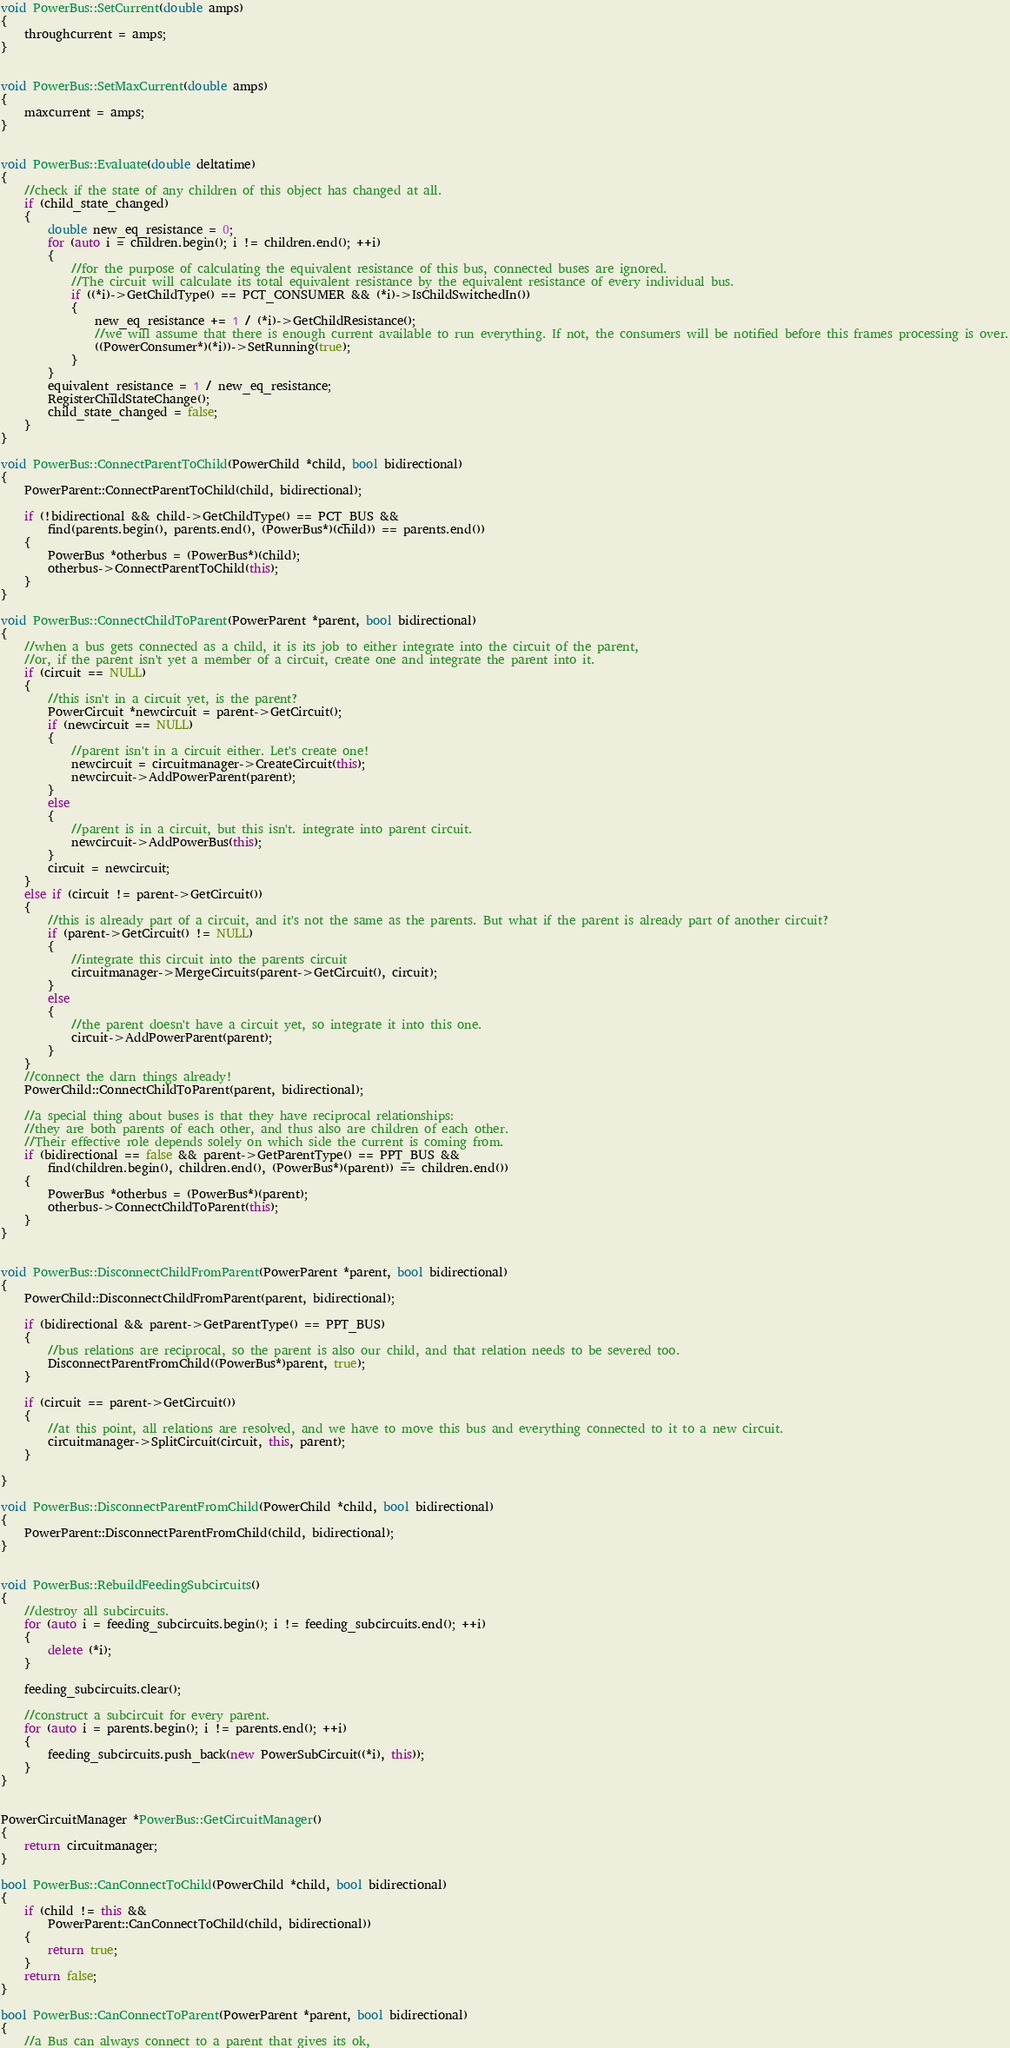<code> <loc_0><loc_0><loc_500><loc_500><_C++_>
void PowerBus::SetCurrent(double amps)
{
	throughcurrent = amps;
}


void PowerBus::SetMaxCurrent(double amps)
{
	maxcurrent = amps;
}


void PowerBus::Evaluate(double deltatime)
{
	//check if the state of any children of this object has changed at all.
	if (child_state_changed)
	{
		double new_eq_resistance = 0;
		for (auto i = children.begin(); i != children.end(); ++i)
		{
			//for the purpose of calculating the equivalent resistance of this bus, connected buses are ignored.
			//The circuit will calculate its total equivalent resistance by the equivalent resistance of every individual bus.
			if ((*i)->GetChildType() == PCT_CONSUMER && (*i)->IsChildSwitchedIn())
			{
				new_eq_resistance += 1 / (*i)->GetChildResistance();
				//we will assume that there is enough current available to run everything. If not, the consumers will be notified before this frames processing is over.
				((PowerConsumer*)(*i))->SetRunning(true);
			}
		}
		equivalent_resistance = 1 / new_eq_resistance;
		RegisterChildStateChange();
		child_state_changed = false;
	}
}

void PowerBus::ConnectParentToChild(PowerChild *child, bool bidirectional)
{
	PowerParent::ConnectParentToChild(child, bidirectional);

	if (!bidirectional && child->GetChildType() == PCT_BUS &&
		find(parents.begin(), parents.end(), (PowerBus*)(child)) == parents.end())
	{
		PowerBus *otherbus = (PowerBus*)(child);
		otherbus->ConnectParentToChild(this);
	}
}

void PowerBus::ConnectChildToParent(PowerParent *parent, bool bidirectional)
{
	//when a bus gets connected as a child, it is its job to either integrate into the circuit of the parent,
	//or, if the parent isn't yet a member of a circuit, create one and integrate the parent into it.
	if (circuit == NULL)
	{
		//this isn't in a circuit yet, is the parent?
		PowerCircuit *newcircuit = parent->GetCircuit();
		if (newcircuit == NULL)
		{
			//parent isn't in a circuit either. Let's create one!
			newcircuit = circuitmanager->CreateCircuit(this);
			newcircuit->AddPowerParent(parent);
		}
		else
		{
			//parent is in a circuit, but this isn't. integrate into parent circuit.
			newcircuit->AddPowerBus(this);
		}
		circuit = newcircuit;
	}
	else if (circuit != parent->GetCircuit())
	{
		//this is already part of a circuit, and it's not the same as the parents. But what if the parent is already part of another circuit?
		if (parent->GetCircuit() != NULL)
		{
			//integrate this circuit into the parents circuit
			circuitmanager->MergeCircuits(parent->GetCircuit(), circuit);
		}
		else
		{
			//the parent doesn't have a circuit yet, so integrate it into this one.
			circuit->AddPowerParent(parent);
		}
	}
	//connect the darn things already!
	PowerChild::ConnectChildToParent(parent, bidirectional);

	//a special thing about buses is that they have reciprocal relationships:
	//they are both parents of each other, and thus also are children of each other.
	//Their effective role depends solely on which side the current is coming from.
	if (bidirectional == false && parent->GetParentType() == PPT_BUS &&
		find(children.begin(), children.end(), (PowerBus*)(parent)) == children.end())
	{
		PowerBus *otherbus = (PowerBus*)(parent);
		otherbus->ConnectChildToParent(this);
	}
}


void PowerBus::DisconnectChildFromParent(PowerParent *parent, bool bidirectional)
{
	PowerChild::DisconnectChildFromParent(parent, bidirectional);

	if (bidirectional && parent->GetParentType() == PPT_BUS)
	{
		//bus relations are reciprocal, so the parent is also our child, and that relation needs to be severed too.
		DisconnectParentFromChild((PowerBus*)parent, true);
	}

	if (circuit == parent->GetCircuit())
	{
		//at this point, all relations are resolved, and we have to move this bus and everything connected to it to a new circuit.
		circuitmanager->SplitCircuit(circuit, this, parent);
	}
	
}

void PowerBus::DisconnectParentFromChild(PowerChild *child, bool bidirectional)
{
	PowerParent::DisconnectParentFromChild(child, bidirectional);
}


void PowerBus::RebuildFeedingSubcircuits()
{
	//destroy all subcircuits.
	for (auto i = feeding_subcircuits.begin(); i != feeding_subcircuits.end(); ++i)
	{
		delete (*i);
	}

	feeding_subcircuits.clear();

	//construct a subcircuit for every parent.
	for (auto i = parents.begin(); i != parents.end(); ++i)
	{
		feeding_subcircuits.push_back(new PowerSubCircuit((*i), this));
	}
}


PowerCircuitManager *PowerBus::GetCircuitManager()
{
	return circuitmanager;
}

bool PowerBus::CanConnectToChild(PowerChild *child, bool bidirectional)
{
	if (child != this &&
		PowerParent::CanConnectToChild(child, bidirectional))
	{
		return true;
	}
	return false;
}

bool PowerBus::CanConnectToParent(PowerParent *parent, bool bidirectional)
{
	//a Bus can always connect to a parent that gives its ok,</code> 